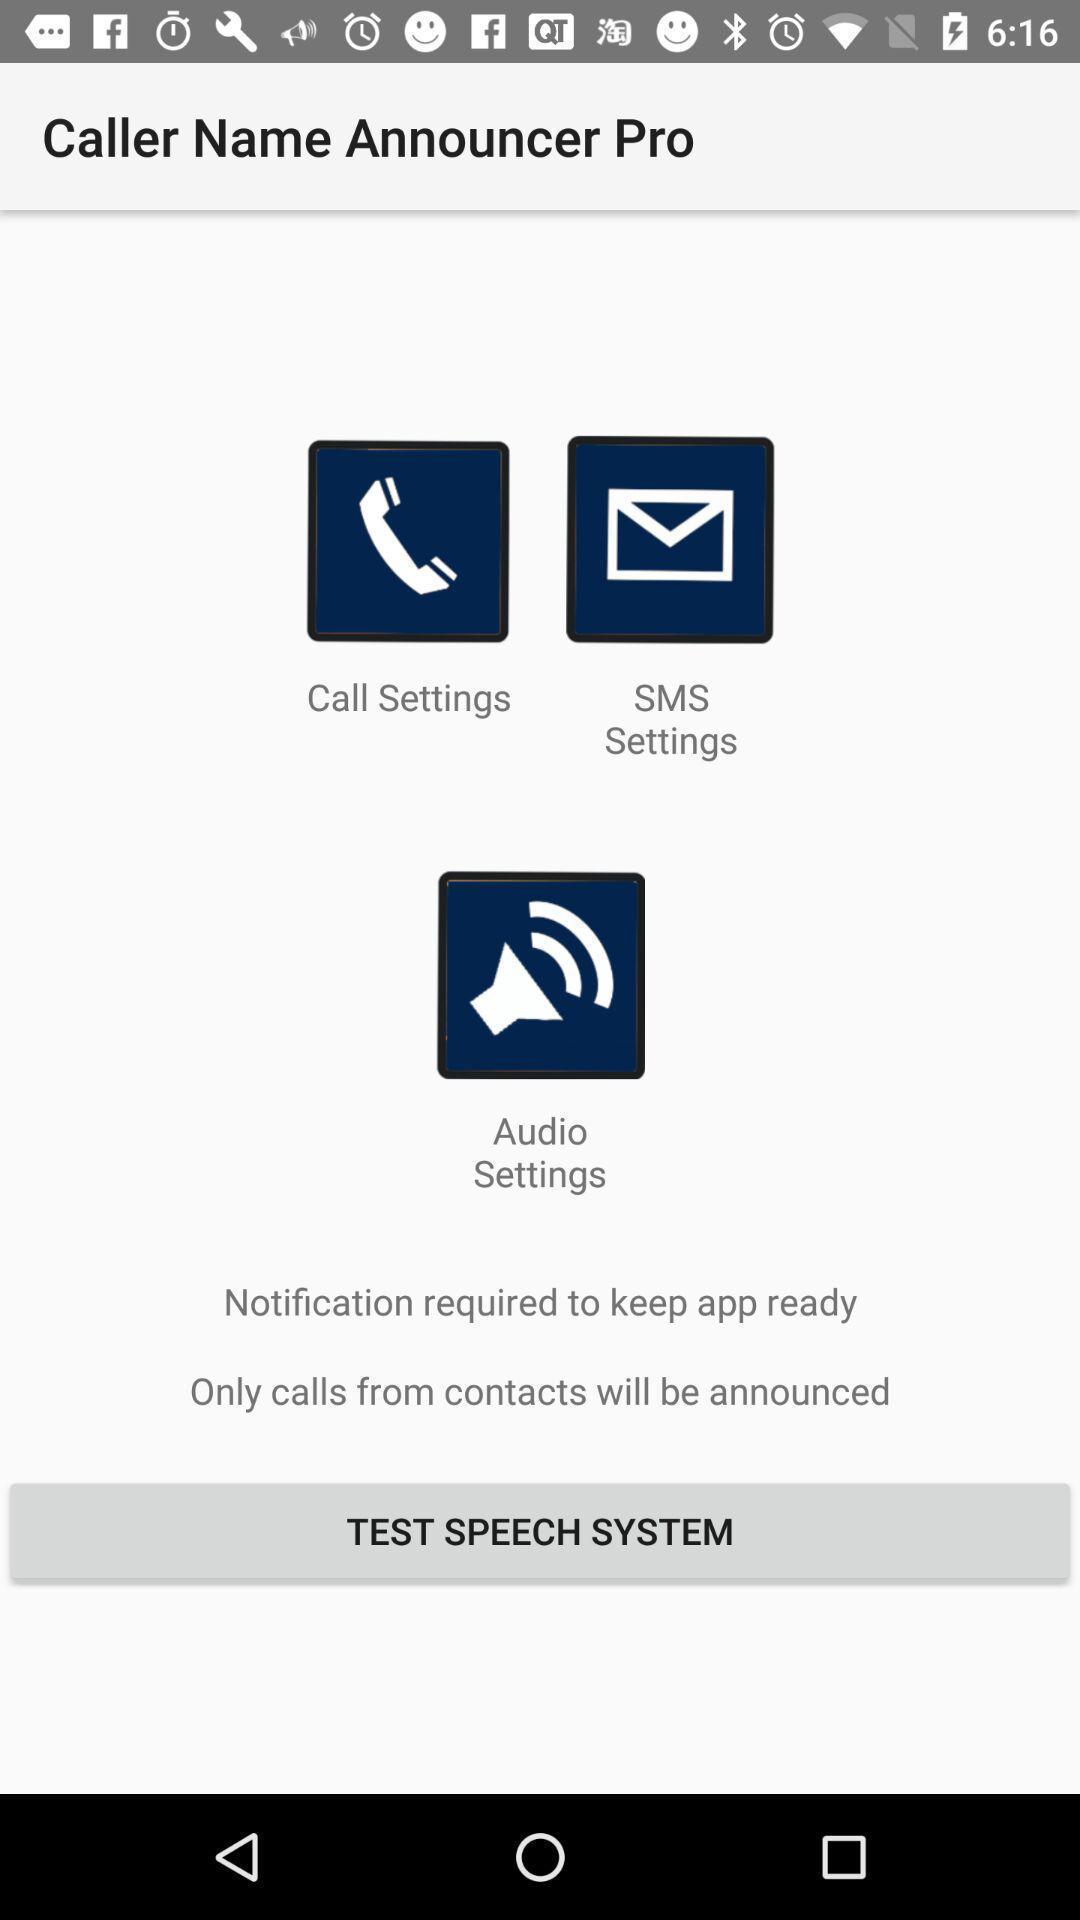Describe the content in this image. Page with options of a calling app. 